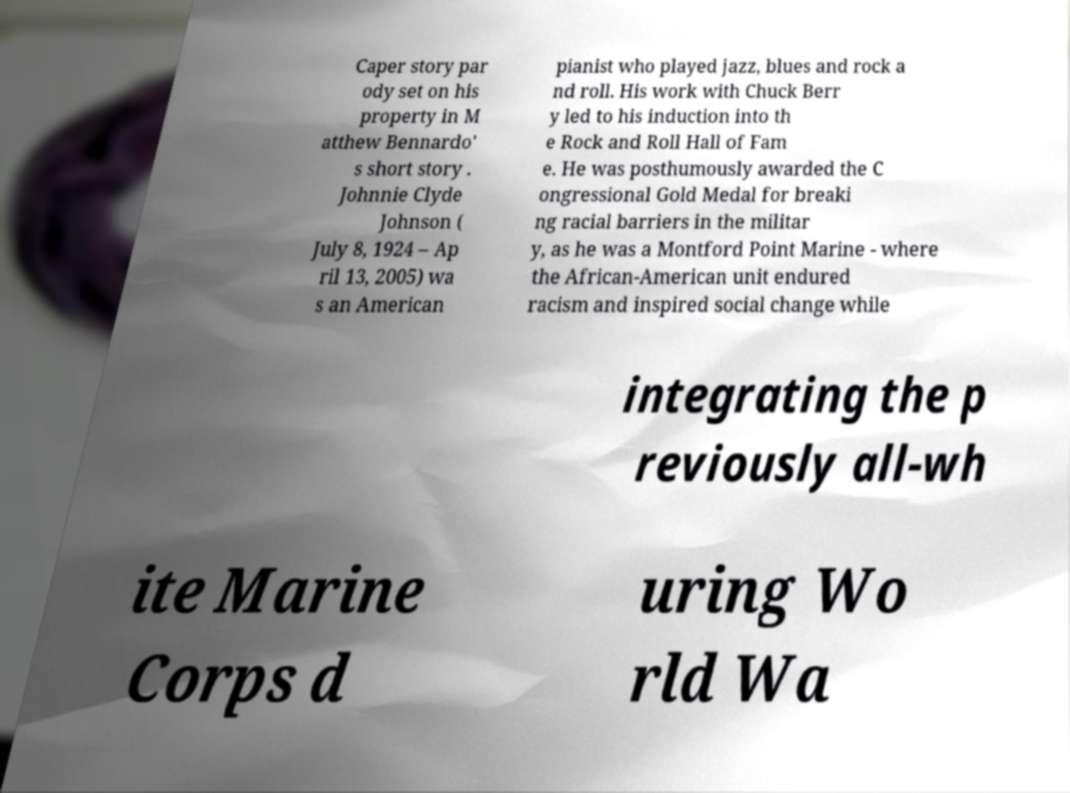Could you assist in decoding the text presented in this image and type it out clearly? Caper story par ody set on his property in M atthew Bennardo' s short story . Johnnie Clyde Johnson ( July 8, 1924 – Ap ril 13, 2005) wa s an American pianist who played jazz, blues and rock a nd roll. His work with Chuck Berr y led to his induction into th e Rock and Roll Hall of Fam e. He was posthumously awarded the C ongressional Gold Medal for breaki ng racial barriers in the militar y, as he was a Montford Point Marine - where the African-American unit endured racism and inspired social change while integrating the p reviously all-wh ite Marine Corps d uring Wo rld Wa 